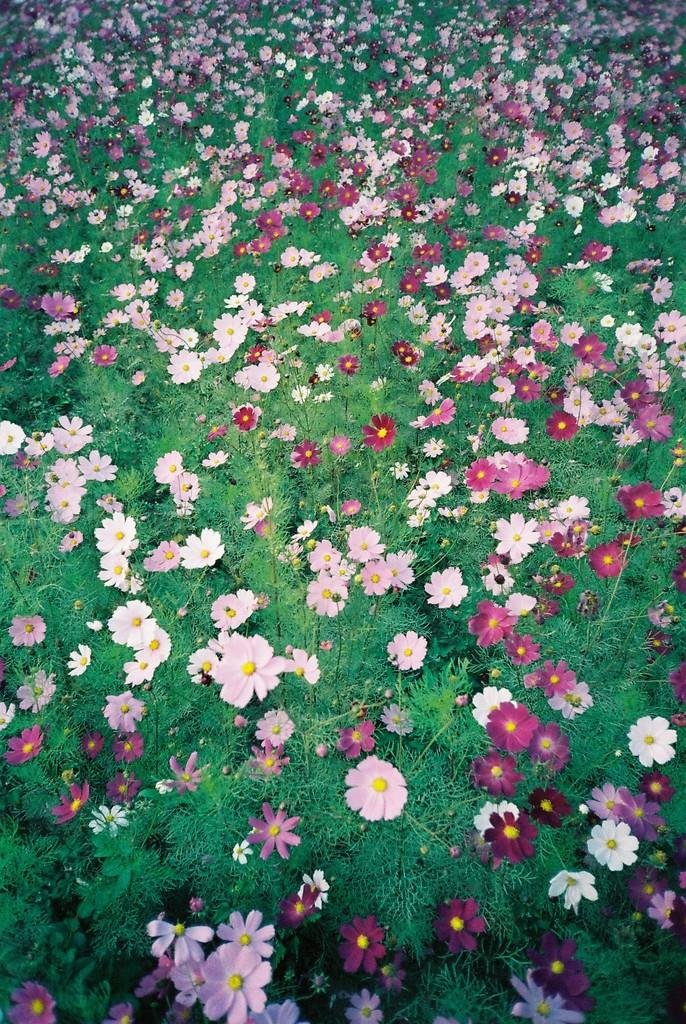What type of living organisms are in the image? The image contains plants. What specific features can be observed on the plants? The plants have flowers. What colors are the flowers? Some flowers are pink in color, and some are light pink in color. Where is the cellar located in the image? There is no cellar present in the image; it features plants with flowers. What type of cord is used to hold the flowers together in the image? There is no cord present in the image; the flowers are attached to the plants. 